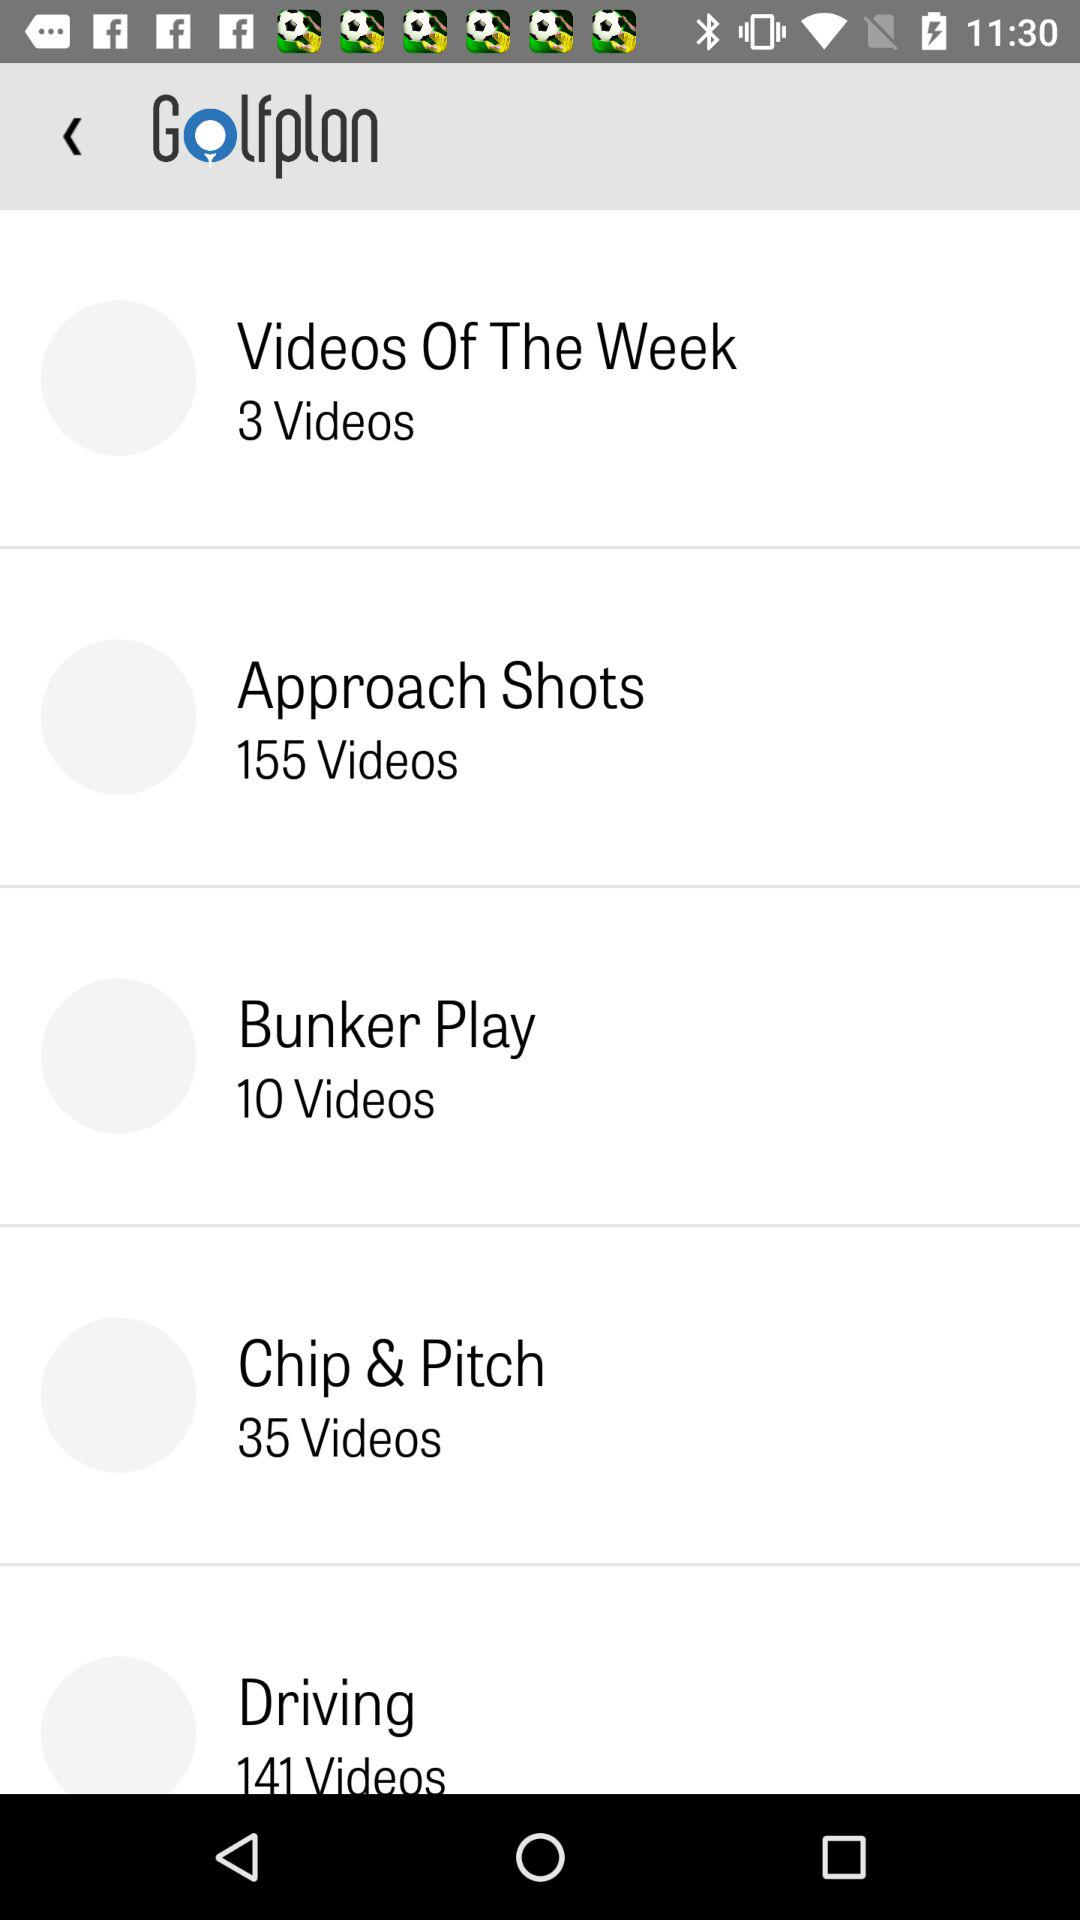How many videos are there in "Chip & Pitch"? There are 35 videos. 